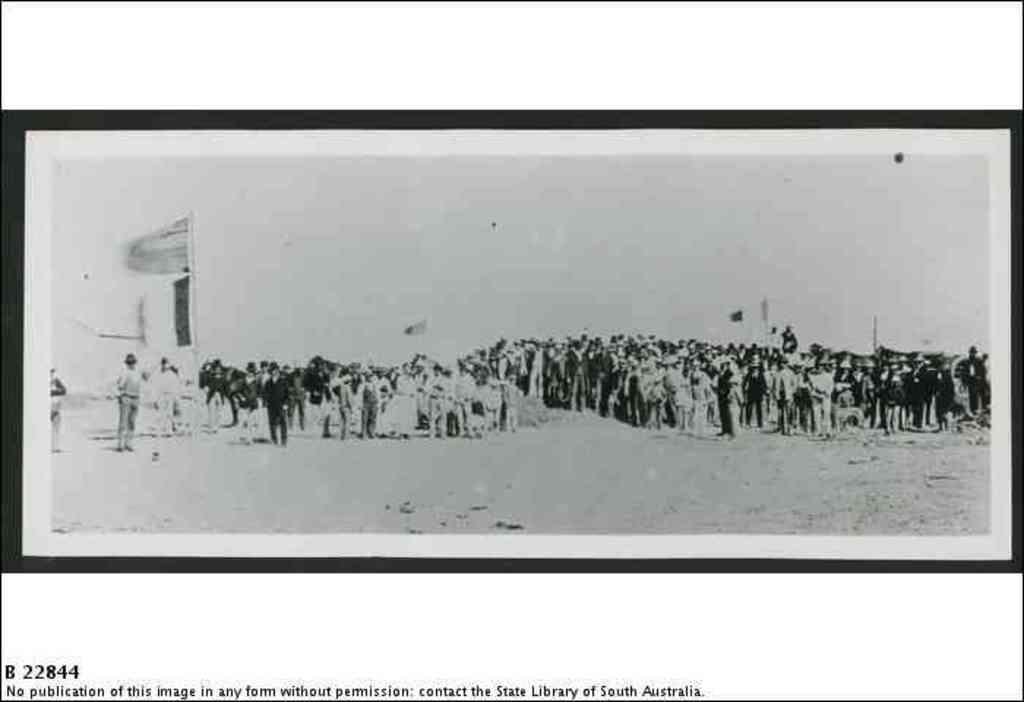<image>
Create a compact narrative representing the image presented. A black and white photograph of many people states it can't be published in any form without permission. 